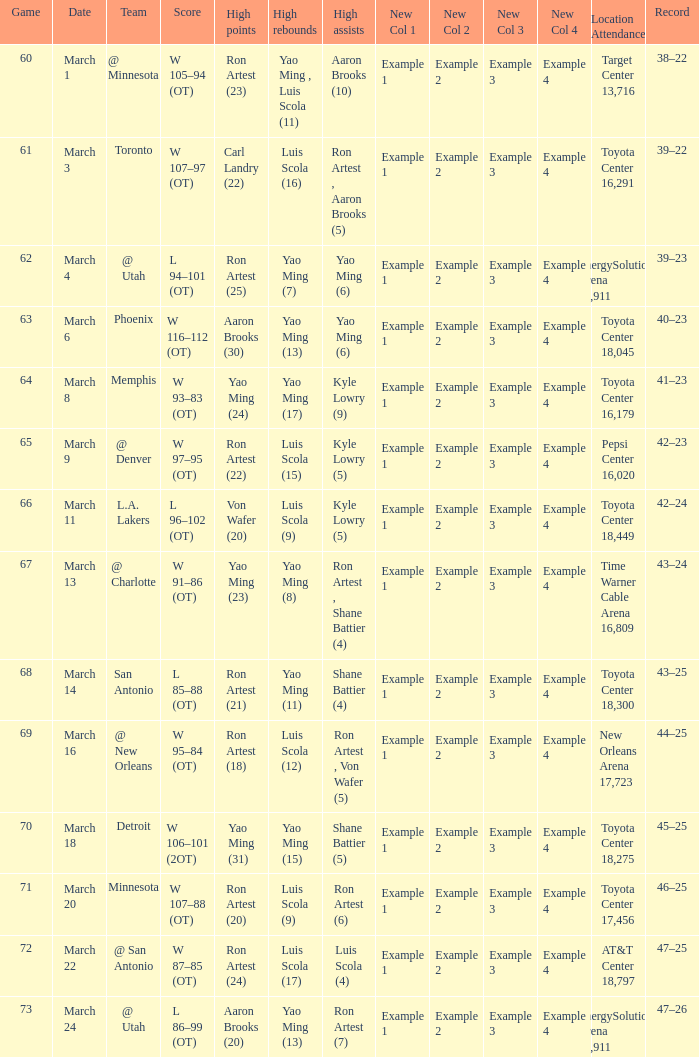On what date did the Rockets play Memphis? March 8. 